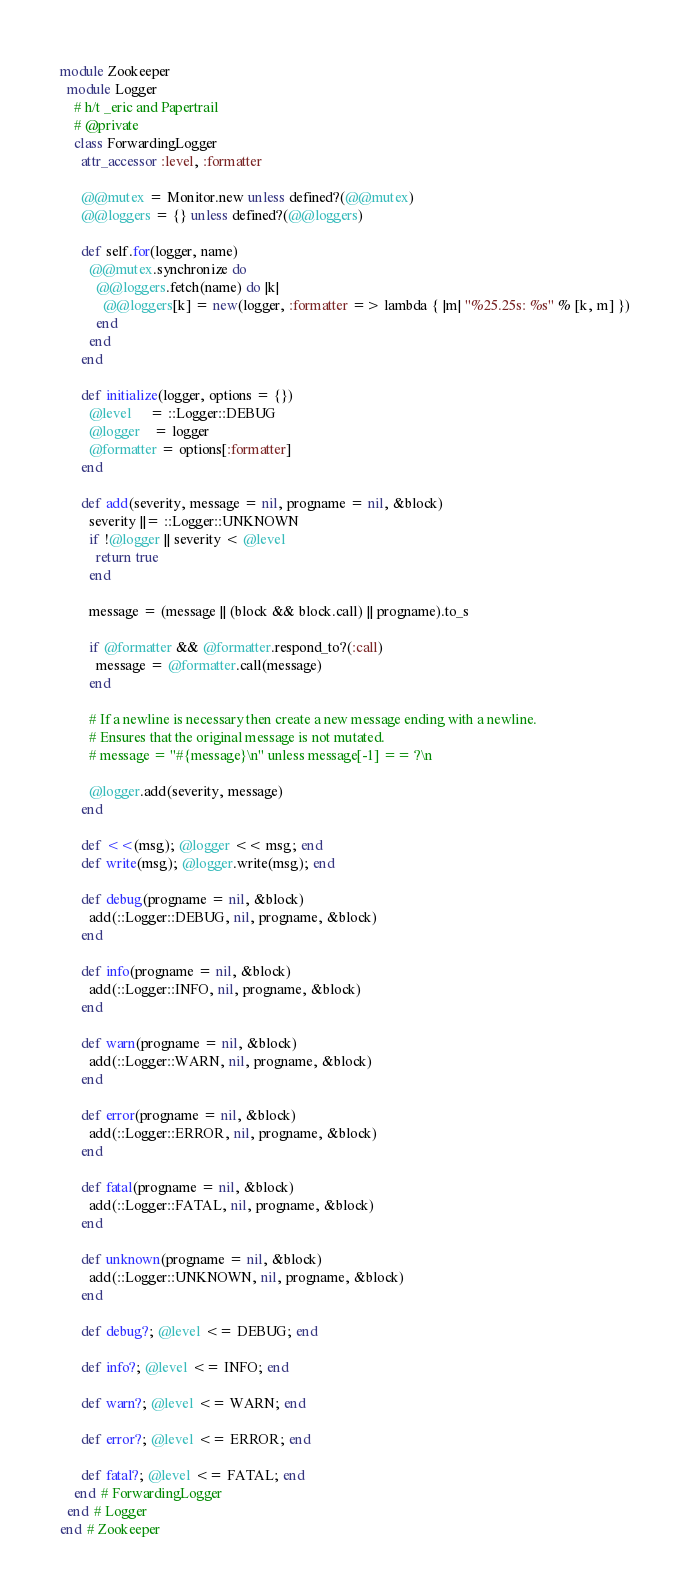Convert code to text. <code><loc_0><loc_0><loc_500><loc_500><_Ruby_>module Zookeeper
  module Logger
    # h/t _eric and Papertrail
    # @private
    class ForwardingLogger
      attr_accessor :level, :formatter

      @@mutex = Monitor.new unless defined?(@@mutex)
      @@loggers = {} unless defined?(@@loggers)

      def self.for(logger, name)
        @@mutex.synchronize do
          @@loggers.fetch(name) do |k|
            @@loggers[k] = new(logger, :formatter => lambda { |m| "%25.25s: %s" % [k, m] })
          end
        end
      end

      def initialize(logger, options = {})
        @level     = ::Logger::DEBUG
        @logger    = logger
        @formatter = options[:formatter]
      end

      def add(severity, message = nil, progname = nil, &block)
        severity ||= ::Logger::UNKNOWN
        if !@logger || severity < @level
          return true
        end
        
        message = (message || (block && block.call) || progname).to_s
        
        if @formatter && @formatter.respond_to?(:call)
          message = @formatter.call(message)
        end

        # If a newline is necessary then create a new message ending with a newline.
        # Ensures that the original message is not mutated.
        # message = "#{message}\n" unless message[-1] == ?\n
        
        @logger.add(severity, message)
      end

      def <<(msg); @logger << msg; end
      def write(msg); @logger.write(msg); end
      
      def debug(progname = nil, &block)
        add(::Logger::DEBUG, nil, progname, &block)
      end
      
      def info(progname = nil, &block)
        add(::Logger::INFO, nil, progname, &block)
      end
      
      def warn(progname = nil, &block)
        add(::Logger::WARN, nil, progname, &block)
      end
      
      def error(progname = nil, &block)
        add(::Logger::ERROR, nil, progname, &block)
      end

      def fatal(progname = nil, &block)
        add(::Logger::FATAL, nil, progname, &block)
      end

      def unknown(progname = nil, &block)
        add(::Logger::UNKNOWN, nil, progname, &block)
      end
      
      def debug?; @level <= DEBUG; end

      def info?; @level <= INFO; end

      def warn?; @level <= WARN; end

      def error?; @level <= ERROR; end

      def fatal?; @level <= FATAL; end
    end # ForwardingLogger
  end # Logger
end # Zookeeper


</code> 